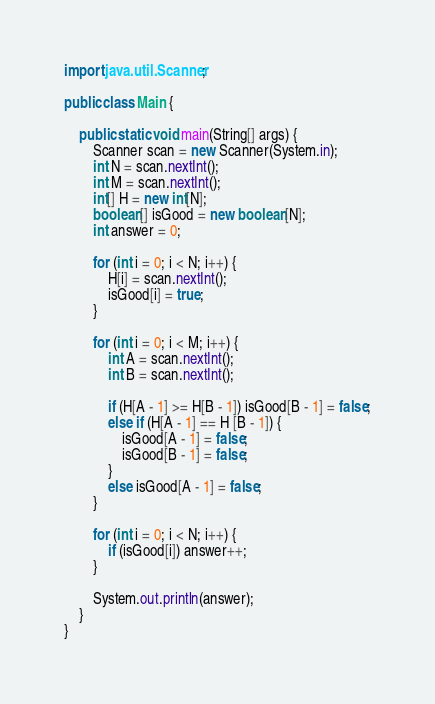Convert code to text. <code><loc_0><loc_0><loc_500><loc_500><_Java_>import java.util.Scanner;

public class Main {

	public static void main(String[] args) {
		Scanner scan = new Scanner(System.in);
		int N = scan.nextInt();
		int M = scan.nextInt();
		int[] H = new int[N];
		boolean[] isGood = new boolean[N];
		int answer = 0;

		for (int i = 0; i < N; i++) {
			H[i] = scan.nextInt();
			isGood[i] = true;
		}

		for (int i = 0; i < M; i++) {
			int A = scan.nextInt();
			int B = scan.nextInt();

			if (H[A - 1] >= H[B - 1]) isGood[B - 1] = false;
			else if (H[A - 1] == H [B - 1]) {
				isGood[A - 1] = false;
				isGood[B - 1] = false;
			}
			else isGood[A - 1] = false;
		}

		for (int i = 0; i < N; i++) {
			if (isGood[i]) answer++;
		}

		System.out.println(answer);
	}
}</code> 